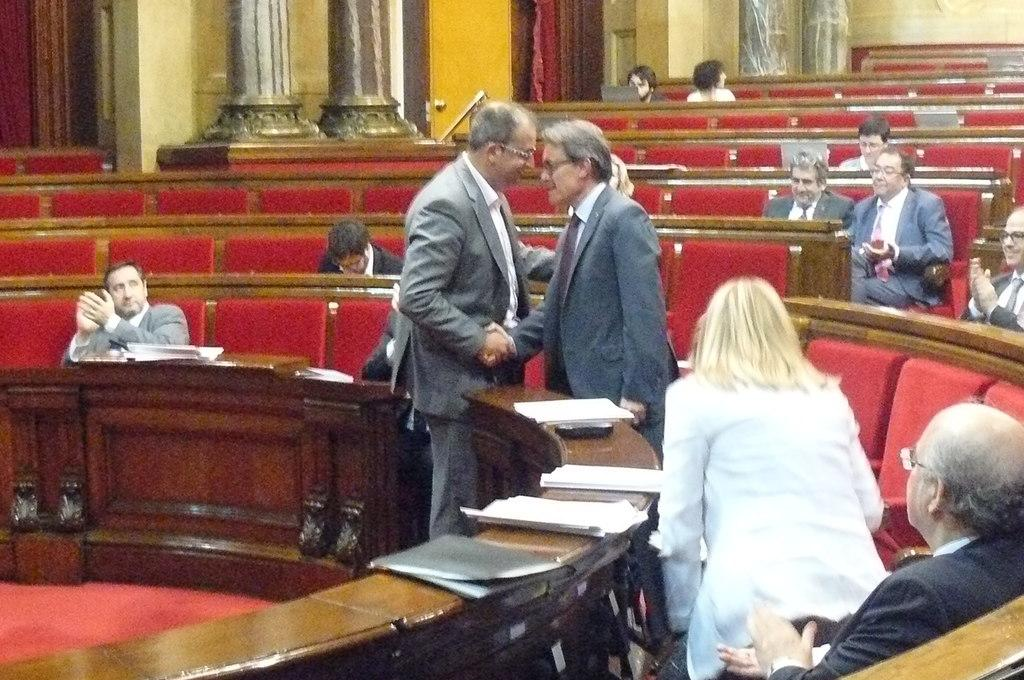What are the people in the image doing? There are people sitting and standing in the image. What objects can be seen on a table in the image? There are papers on a table in the image. What architectural features are visible in the background of the image? There are pillars in the background of the image. Can you tell me how many drums are being played in the image? There are no drums present in the image. What type of hydrant is visible in the image? There is no hydrant present in the image. 